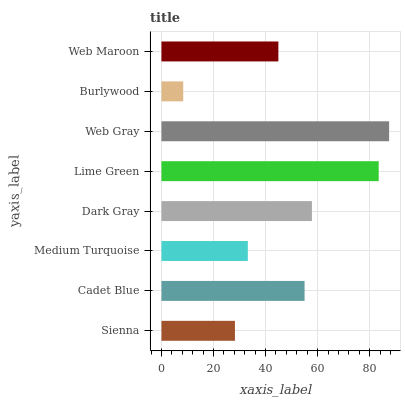Is Burlywood the minimum?
Answer yes or no. Yes. Is Web Gray the maximum?
Answer yes or no. Yes. Is Cadet Blue the minimum?
Answer yes or no. No. Is Cadet Blue the maximum?
Answer yes or no. No. Is Cadet Blue greater than Sienna?
Answer yes or no. Yes. Is Sienna less than Cadet Blue?
Answer yes or no. Yes. Is Sienna greater than Cadet Blue?
Answer yes or no. No. Is Cadet Blue less than Sienna?
Answer yes or no. No. Is Cadet Blue the high median?
Answer yes or no. Yes. Is Web Maroon the low median?
Answer yes or no. Yes. Is Web Maroon the high median?
Answer yes or no. No. Is Sienna the low median?
Answer yes or no. No. 